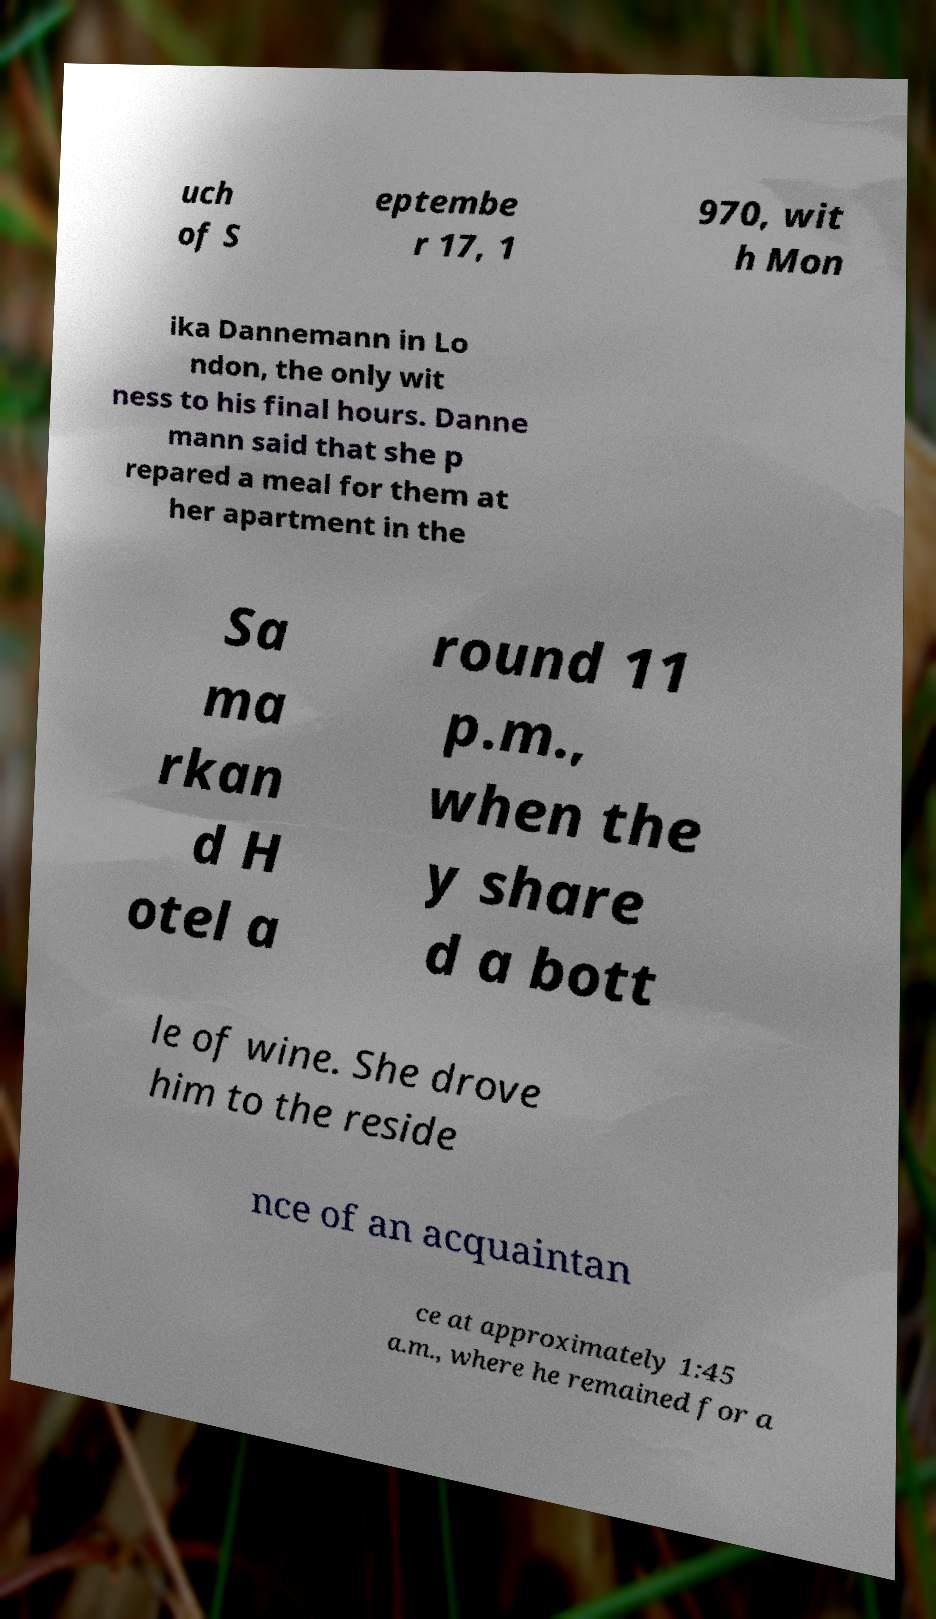There's text embedded in this image that I need extracted. Can you transcribe it verbatim? uch of S eptembe r 17, 1 970, wit h Mon ika Dannemann in Lo ndon, the only wit ness to his final hours. Danne mann said that she p repared a meal for them at her apartment in the Sa ma rkan d H otel a round 11 p.m., when the y share d a bott le of wine. She drove him to the reside nce of an acquaintan ce at approximately 1:45 a.m., where he remained for a 